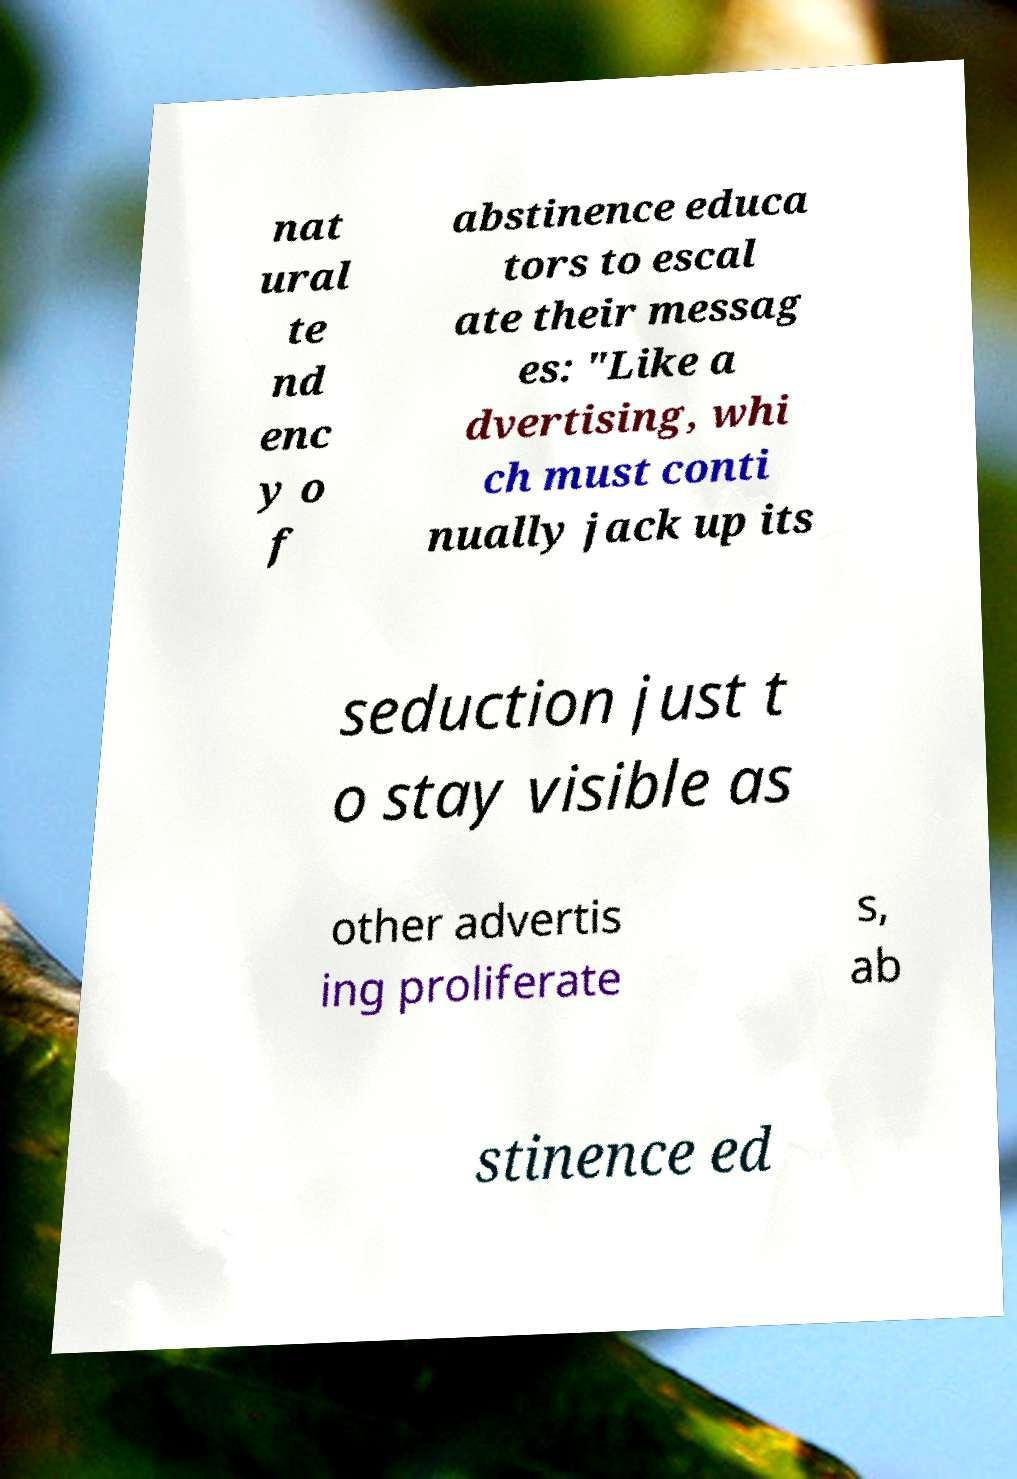Can you accurately transcribe the text from the provided image for me? nat ural te nd enc y o f abstinence educa tors to escal ate their messag es: "Like a dvertising, whi ch must conti nually jack up its seduction just t o stay visible as other advertis ing proliferate s, ab stinence ed 